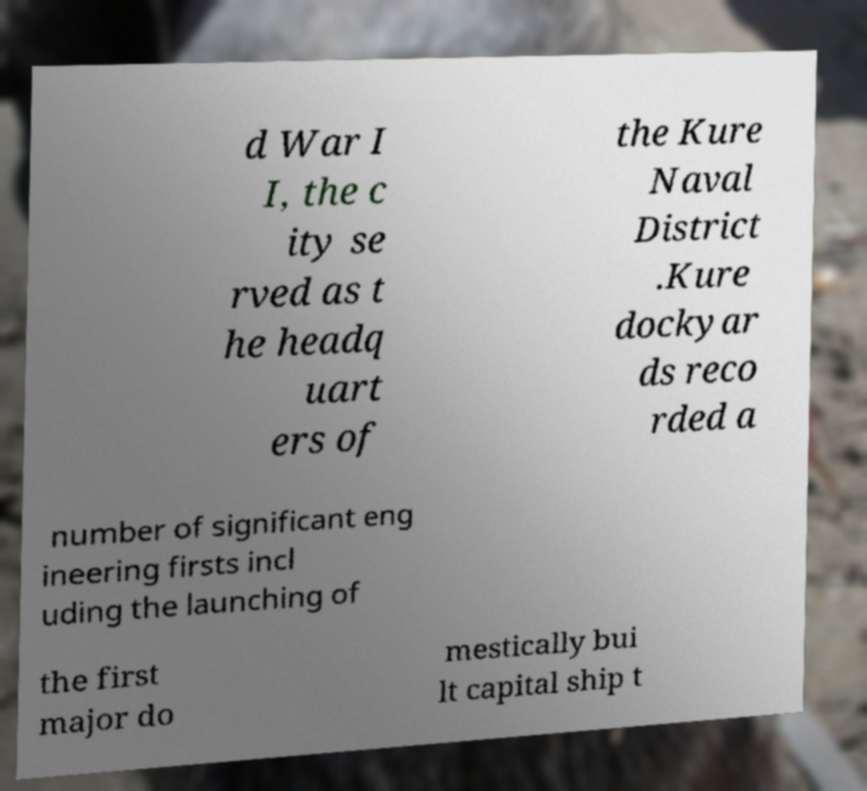Can you accurately transcribe the text from the provided image for me? d War I I, the c ity se rved as t he headq uart ers of the Kure Naval District .Kure dockyar ds reco rded a number of significant eng ineering firsts incl uding the launching of the first major do mestically bui lt capital ship t 